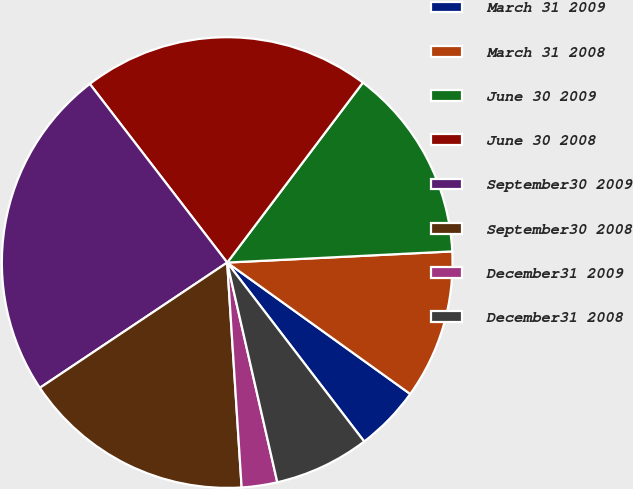Convert chart. <chart><loc_0><loc_0><loc_500><loc_500><pie_chart><fcel>March 31 2009<fcel>March 31 2008<fcel>June 30 2009<fcel>June 30 2008<fcel>September30 2009<fcel>September30 2008<fcel>December31 2009<fcel>December31 2008<nl><fcel>4.69%<fcel>10.7%<fcel>13.93%<fcel>20.72%<fcel>23.95%<fcel>16.64%<fcel>2.55%<fcel>6.83%<nl></chart> 